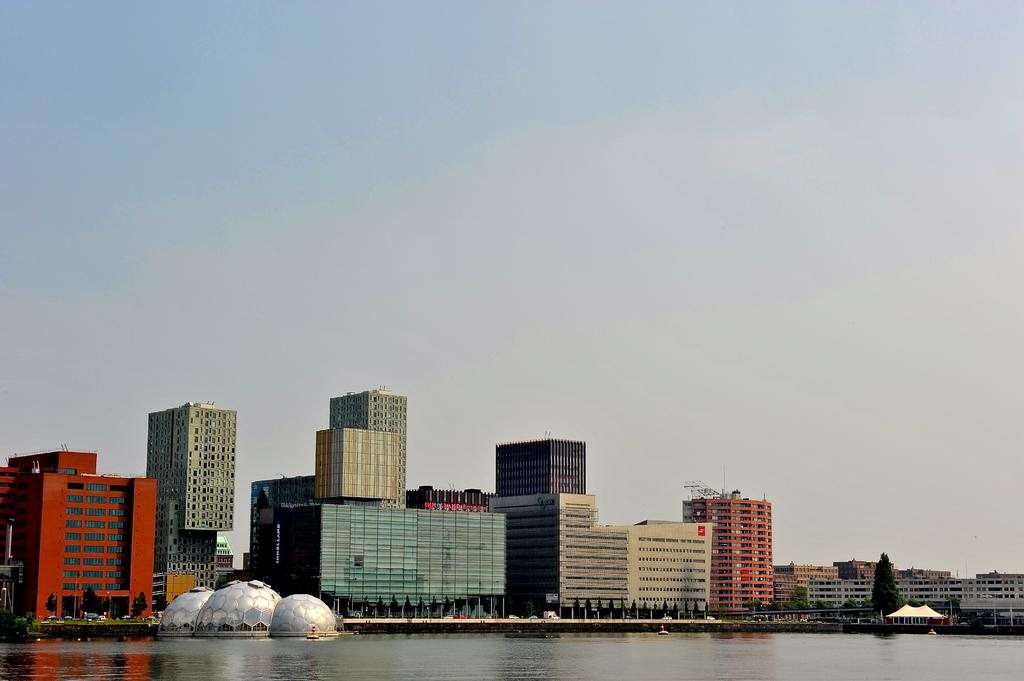What is visible in the foreground of the image? There is water in the foreground of the image. What can be seen in the center of the image? There are buildings, trees, and vehicles in the center of the image. What is the weather like in the image? The sky is sunny in the image. How much wealth is represented by the buildings in the image? The image does not provide information about the wealth represented by the buildings. What type of money can be seen in the image? There is no money visible in the image. 